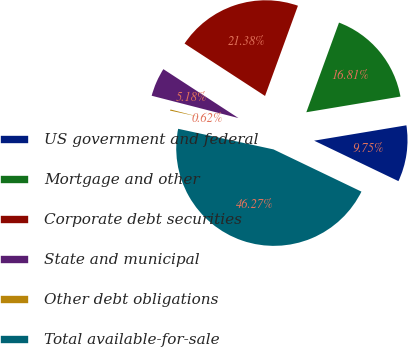<chart> <loc_0><loc_0><loc_500><loc_500><pie_chart><fcel>US government and federal<fcel>Mortgage and other<fcel>Corporate debt securities<fcel>State and municipal<fcel>Other debt obligations<fcel>Total available-for-sale<nl><fcel>9.75%<fcel>16.81%<fcel>21.38%<fcel>5.18%<fcel>0.62%<fcel>46.27%<nl></chart> 